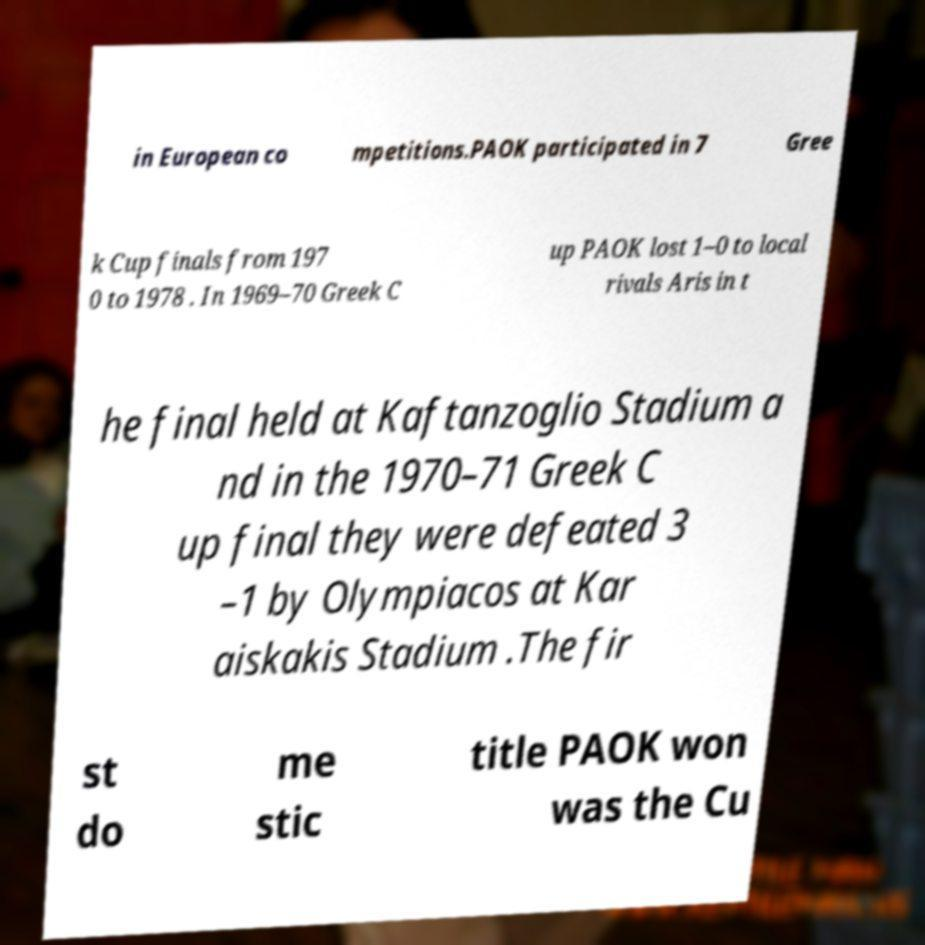Can you accurately transcribe the text from the provided image for me? in European co mpetitions.PAOK participated in 7 Gree k Cup finals from 197 0 to 1978 . In 1969–70 Greek C up PAOK lost 1–0 to local rivals Aris in t he final held at Kaftanzoglio Stadium a nd in the 1970–71 Greek C up final they were defeated 3 –1 by Olympiacos at Kar aiskakis Stadium .The fir st do me stic title PAOK won was the Cu 